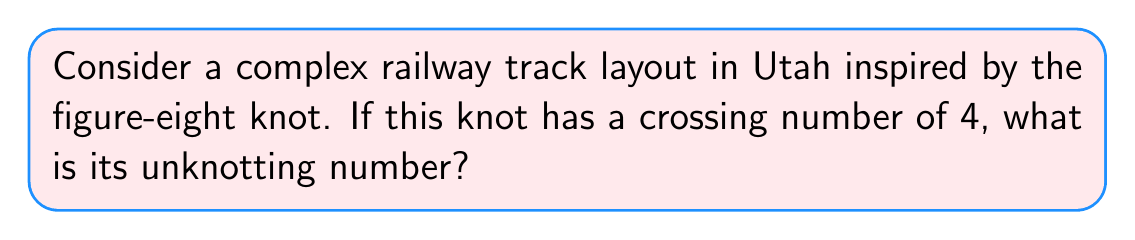Teach me how to tackle this problem. To determine the unknotting number of the figure-eight knot, we need to follow these steps:

1. Understand the definition: The unknotting number is the minimum number of crossing changes required to transform a knot into the unknot (trivial knot).

2. Analyze the figure-eight knot:
   - The figure-eight knot is the simplest non-trivial knot after the trefoil knot.
   - It has a crossing number of 4, which means it has 4 crossings in its minimal diagram.

3. Consider possible unknotting sequences:
   - Changing one crossing is not sufficient to unknot the figure-eight knot.
   - Changing two crossings in a specific way can unknot the figure-eight knot.

4. Prove minimality:
   - The unknotting number is always less than or equal to half the crossing number.
   - For the figure-eight knot: $\text{unknotting number} \leq \lfloor \frac{4}{2} \rfloor = 2$
   - We found a sequence that achieves this upper bound.
   - It can be proven that changing only one crossing cannot unknot the figure-eight knot.

5. Conclusion:
   The unknotting number of the figure-eight knot is 2.

This analysis applies to the railway track layout inspired by the figure-eight knot, providing insight into the complexity of the infrastructure design in Utah.
Answer: 2 